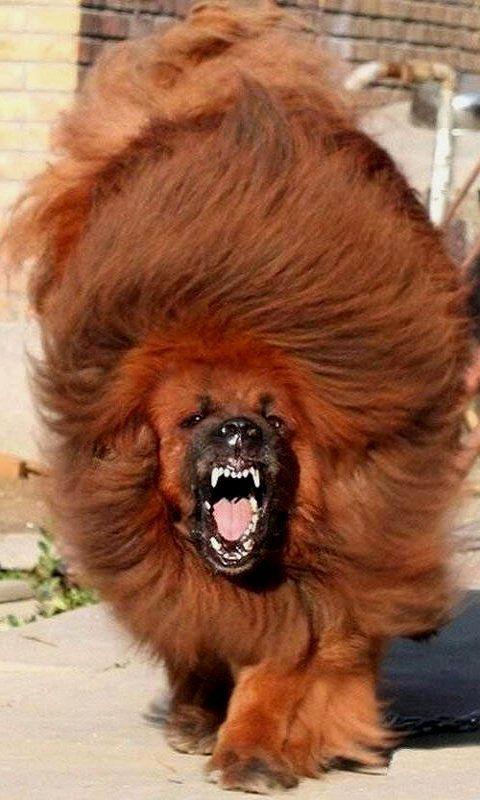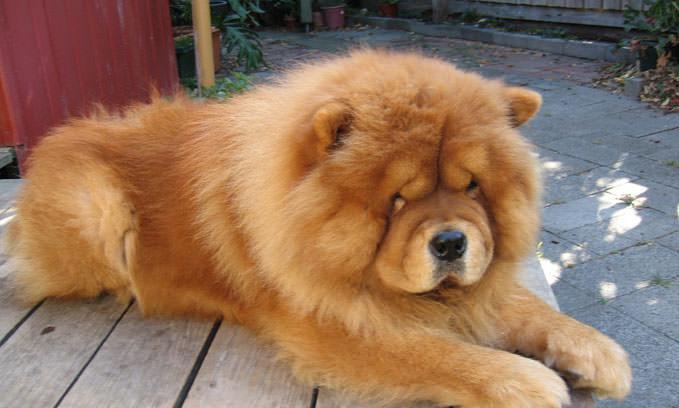The first image is the image on the left, the second image is the image on the right. Assess this claim about the two images: "The pair of pictures shows exactly two dogs and no human.". Correct or not? Answer yes or no. Yes. The first image is the image on the left, the second image is the image on the right. For the images shown, is this caption "The left image contains a human holding a chow dog." true? Answer yes or no. No. 